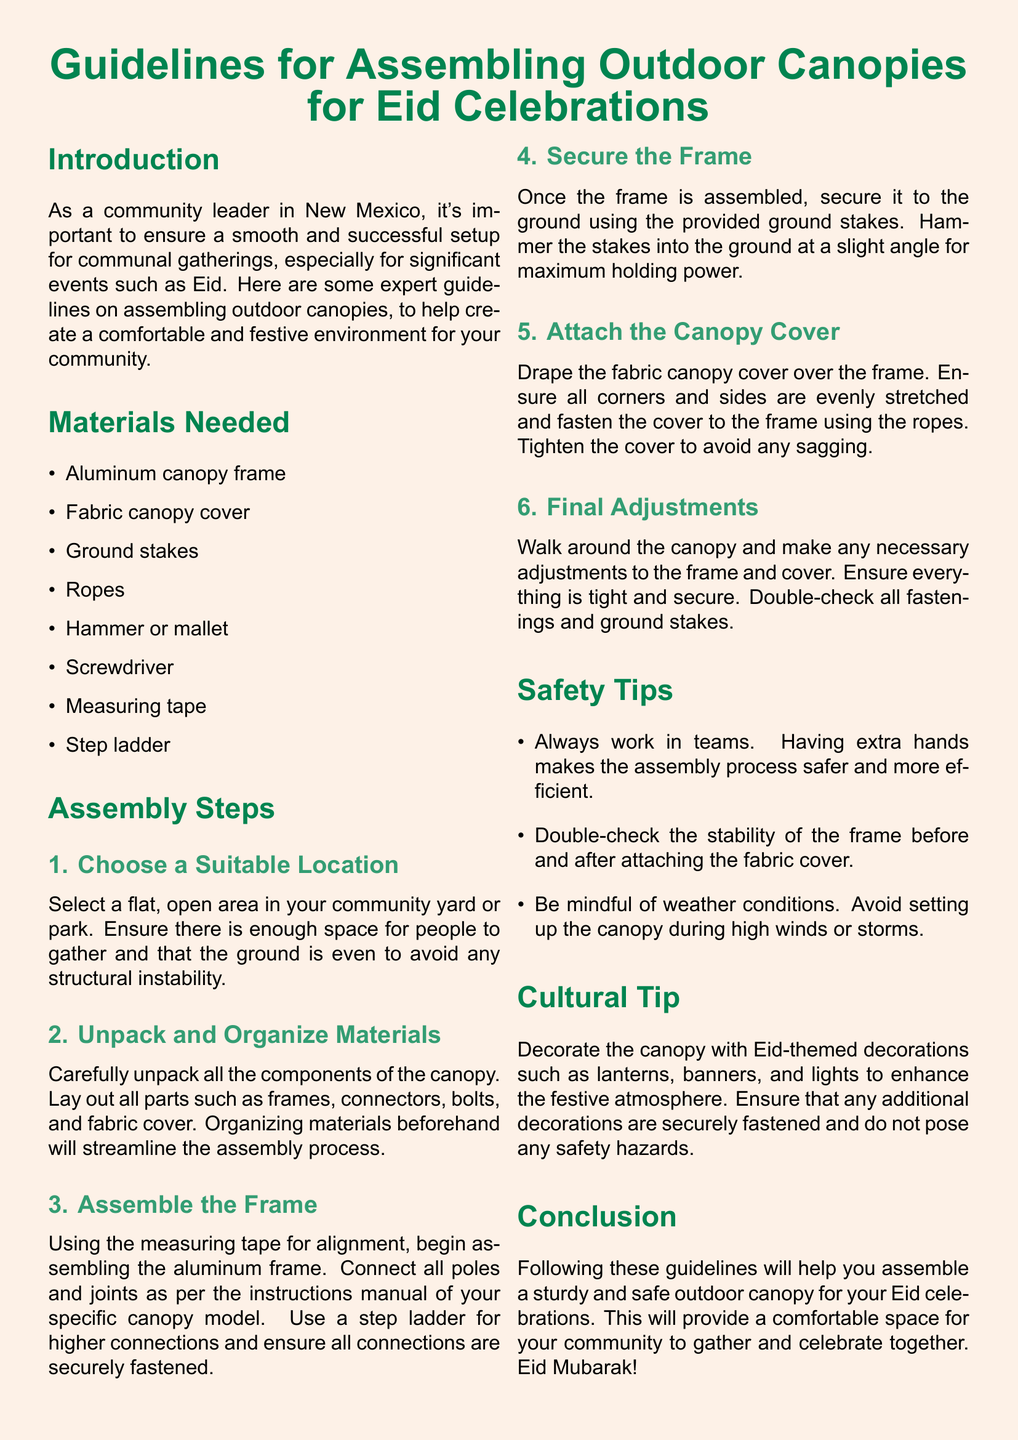What is the main purpose of the document? The document provides guidelines for assembling outdoor canopies specifically for Eid celebrations in the community.
Answer: Guidelines for assembling outdoor canopies for Eid celebrations How many items are listed in the materials needed section? The materials needed section contains a list of items that are required for assembling the canopies. There are eight items in total.
Answer: Eight What should be done to secure the frame? The guidelines specify that the frame should be secured to the ground using ground stakes.
Answer: Ground stakes What is the final adjustment step in the Assembly Steps? The final adjustment step involves ensuring everything is tight and secure and double-checking all fastenings and ground stakes.
Answer: Final Adjustments What color is used for the section titles in the document? The color used for the section titles is a shade of green specified as "islamicgreen."
Answer: Islamic green Why is it advised to work in teams? The document states that having extra hands makes the assembly process safer and more efficient.
Answer: Safer and more efficient What should be avoided while assembling the canopy? The guidelines suggest avoiding setting up the canopy during high winds or storms to ensure safety.
Answer: High winds or storms What type of decorations are recommended for the canopy? The cultural tip suggests using Eid-themed decorations to enhance the festive atmosphere.
Answer: Eid-themed decorations 